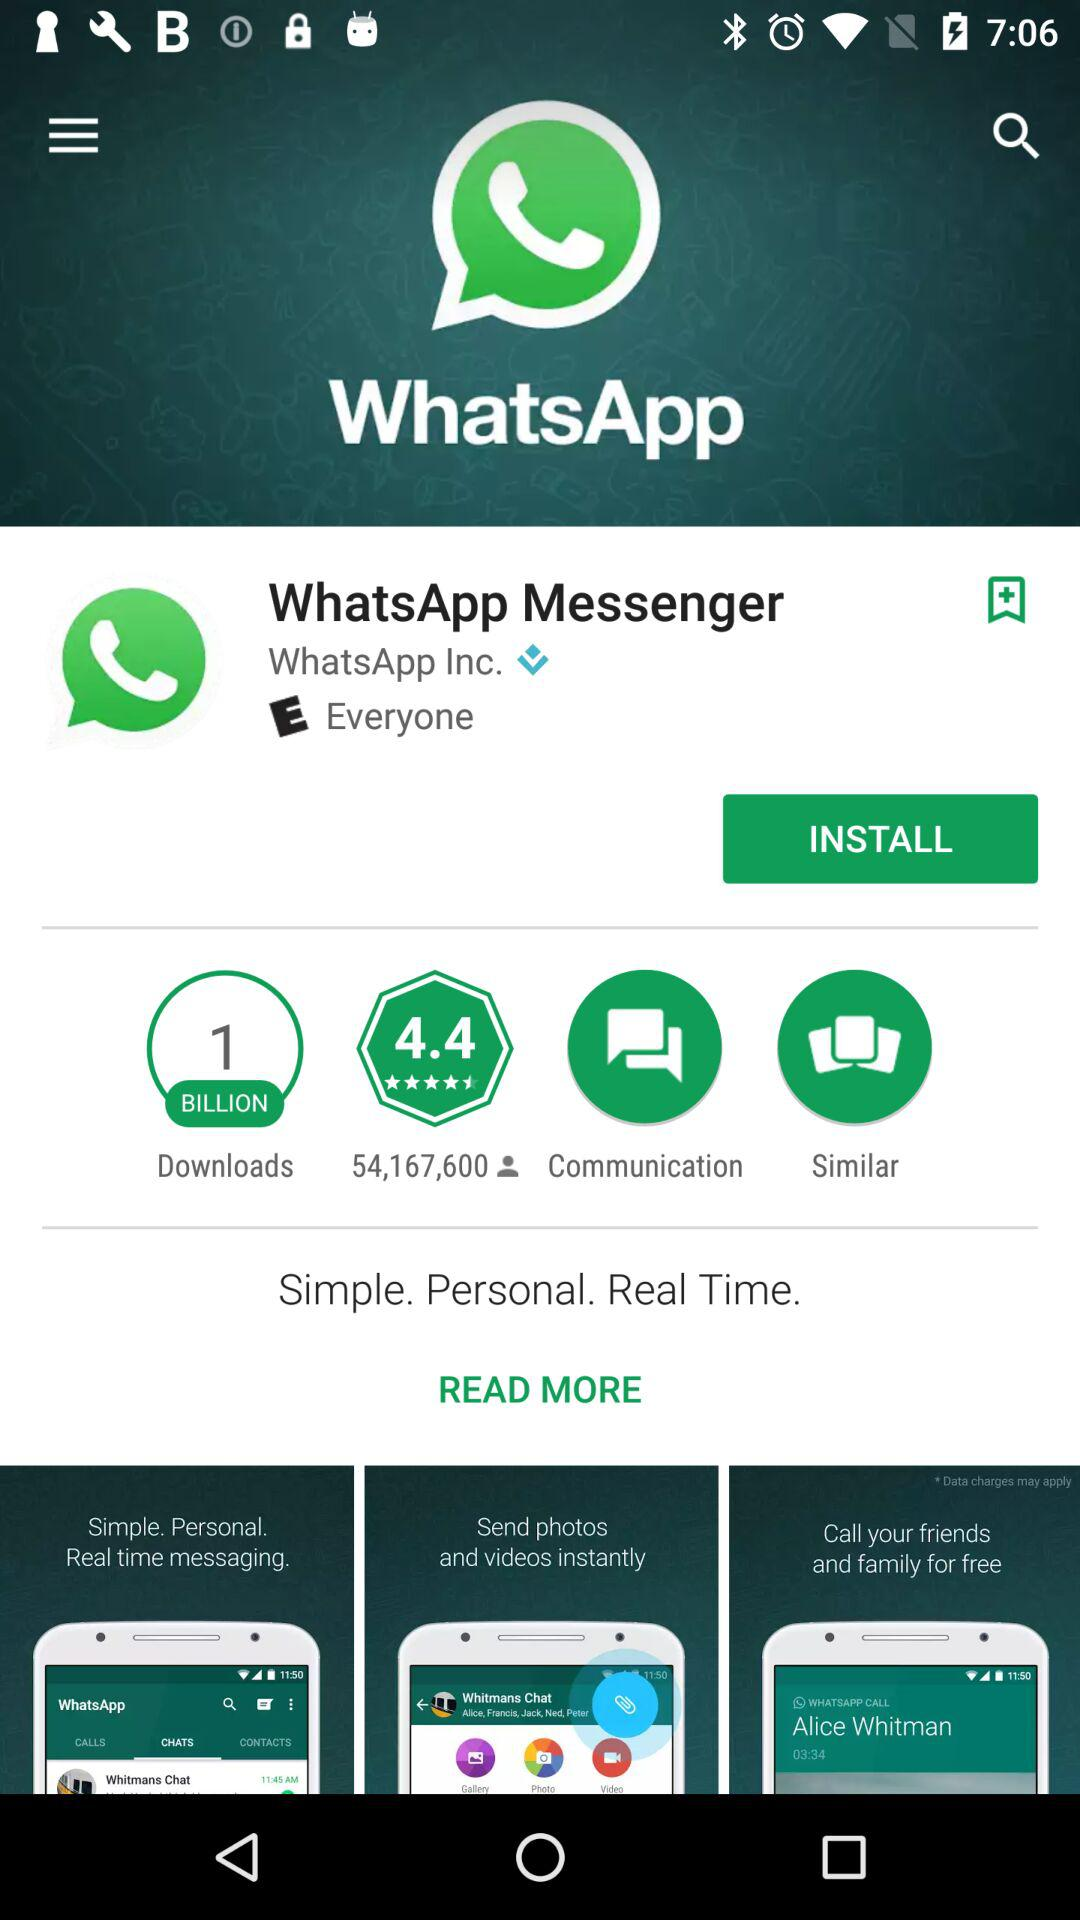What is the install app name?
When the provided information is insufficient, respond with <no answer>. <no answer> 